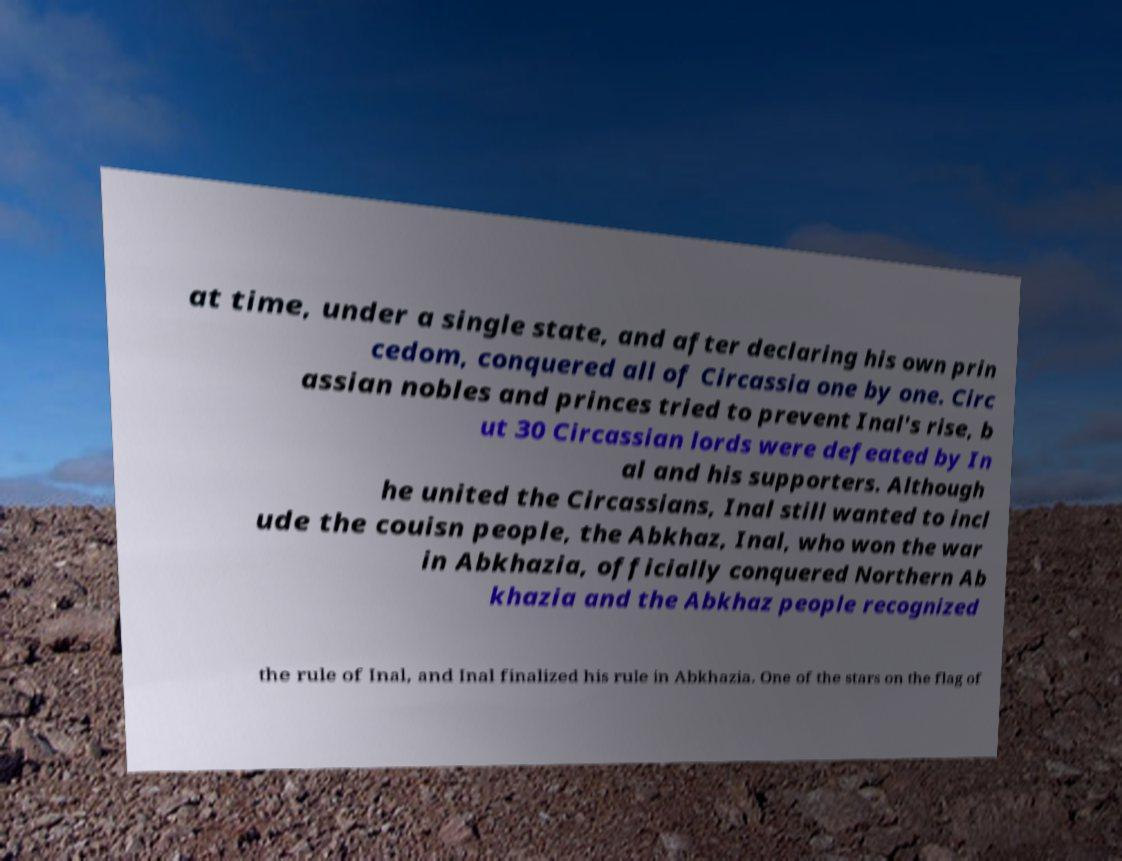Could you assist in decoding the text presented in this image and type it out clearly? at time, under a single state, and after declaring his own prin cedom, conquered all of Circassia one by one. Circ assian nobles and princes tried to prevent Inal's rise, b ut 30 Circassian lords were defeated by In al and his supporters. Although he united the Circassians, Inal still wanted to incl ude the couisn people, the Abkhaz, Inal, who won the war in Abkhazia, officially conquered Northern Ab khazia and the Abkhaz people recognized the rule of Inal, and Inal finalized his rule in Abkhazia. One of the stars on the flag of 